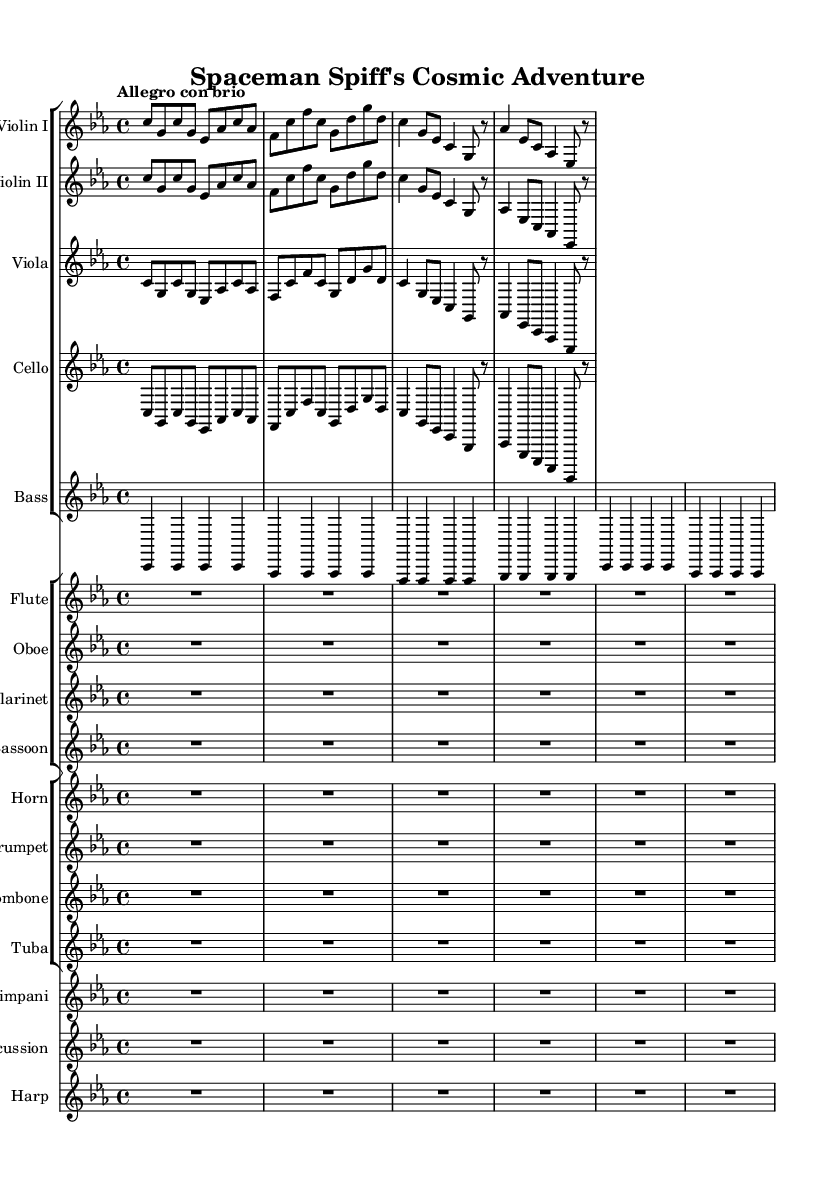What is the key signature of this music? The key signature is C minor, which features three flats: B flat, E flat, and A flat. This can be identified at the beginning of the staff, where the flats are indicated.
Answer: C minor What is the time signature of this music? The time signature is 4/4, meaning there are four beats in a measure and each beat is a quarter note. This is located next to the key signature at the beginning of the staff.
Answer: 4/4 What is the tempo marking of this piece? The tempo marking is "Allegro con brio," which indicates a lively and brisk speed. This is stated above the measures at the beginning of the score.
Answer: Allegro con brio How many instruments are included in this symphony? There are fifteen instruments listed in the score. This can be counted by observing each staff group and its corresponding instruments.
Answer: Fifteen What is the dynamic change at measure five for the violins? In measure five, the dynamic indicated is forte for both violins, which instructs the players to perform the passage loudly. The dynamic markings are typically placed below the staff.
Answer: Forte How do the melodies for Violin I and Violin II compare in the first phrase? The melodies for Violin I and II are identical in the first phrase, as they play the same sequence of notes in parallel throughout the opening measures. This can be seen visually as both violin parts share the same notation for the initial measures.
Answer: Identical 